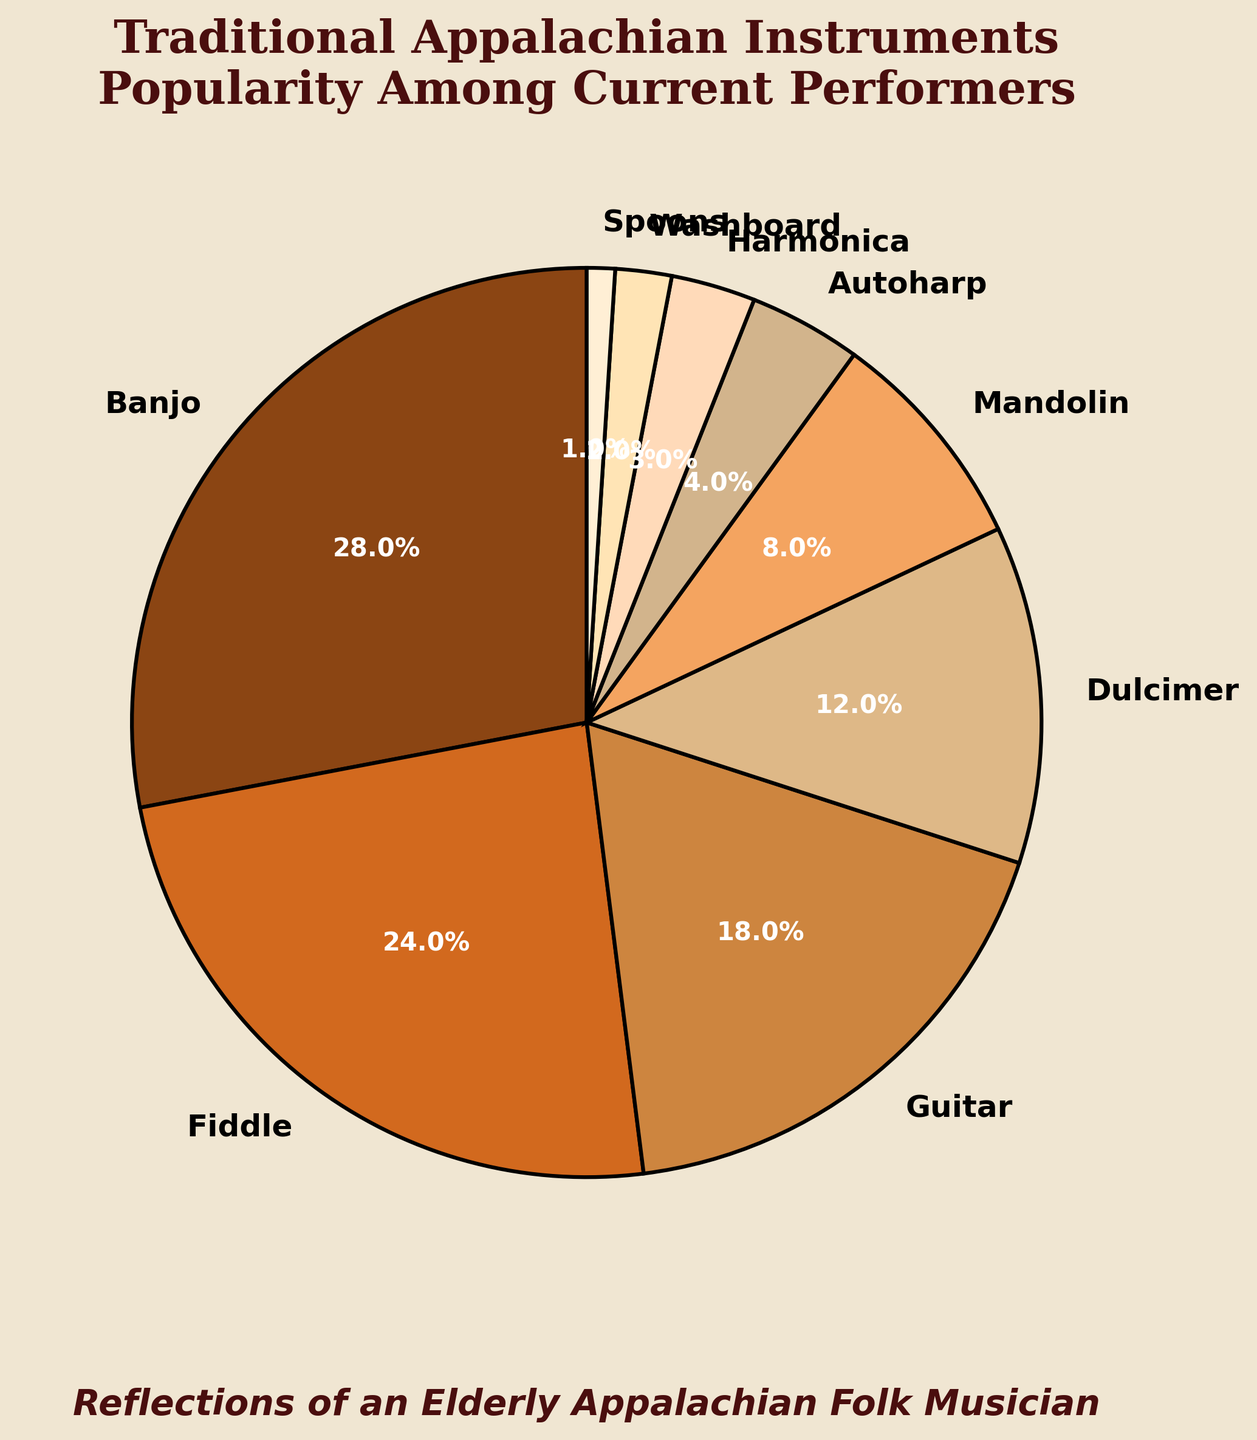Which instrument is the most popular among current performers? The instrument with the highest percentage is the most popular. Looking at the pie chart, the Banjo has the highest percentage at 28%.
Answer: Banjo What is the combined percentage of musicians who play the Fiddle and Guitar? To find the combined percentage, add the individual percentages of the Fiddle and Guitar. Fiddle is 24% and Guitar is 18%. So, 24% + 18% = 42%.
Answer: 42% Which instrument is more popular, the Mandolin or the Dulcimer? Compare the percentages of the Mandolin and Dulcimer. Mandolin is at 8% and Dulcimer at 12%. Since 8% < 12%, the Dulcimer is more popular.
Answer: Dulcimer How many instruments have a popularity of 10% or less? Count the instruments with a percentage of 10% or less. The instruments are Mandolin (8%), Autoharp (4%), Harmonica (3%), Washboard (2%), and Spoons (1%). There are 5 such instruments.
Answer: 5 What is the total percentage of performers who play the Autoharp, Harmonica, Washboard, and Spoons? Add the percentages of the Autoharp (4%), Harmonica (3%), Washboard (2%), and Spoons (1%). So, 4% + 3% + 2% + 1% = 10%.
Answer: 10% Which instrument is least popular among current performers? The instrument with the smallest percentage is the least popular. The Spoons have the smallest percentage at 1%.
Answer: Spoons How much more popular is the Banjo compared to the Harmonica? Subtract the percentage of the Harmonica from the percentage of the Banjo. Banjo is 28% and Harmonica is 3%. So, 28% - 3% = 25%.
Answer: 25% Which instruments have percentages that are visually represented with colors in the brown spectrum? All instruments are represented with colors in the brown spectrum. To identify which ones, we look at the text to recall they include Banjo, Fiddle, Guitar, Dulcimer, Mandolin, Autoharp, Harmonica, Washboard, and Spoons. All instruments fall in this category.
Answer: All 